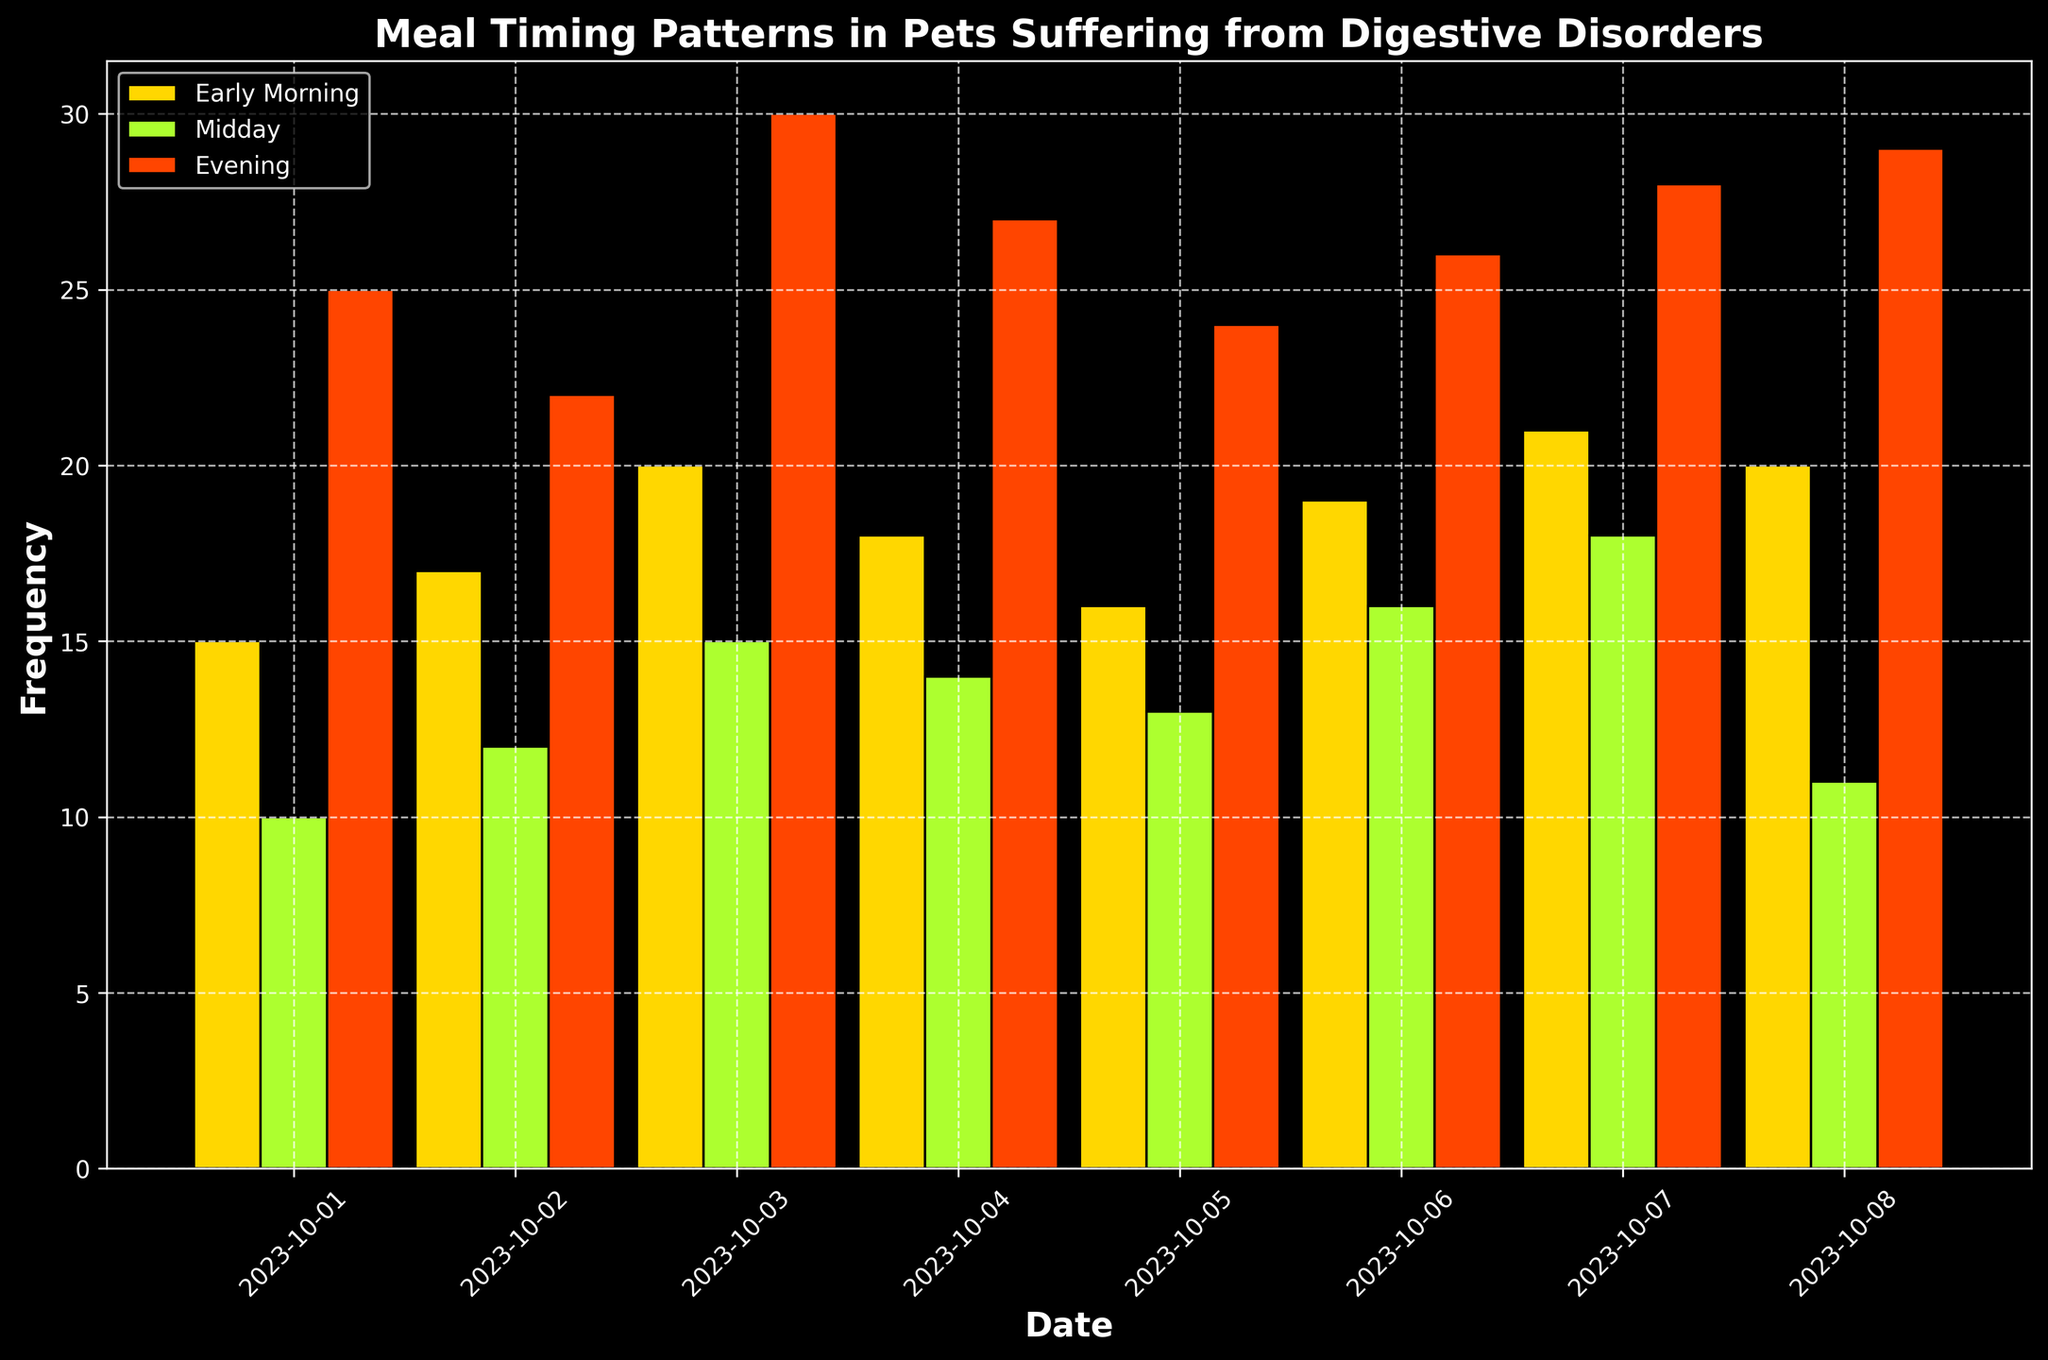1. Which meal timing category has the highest frequency on 2023-10-03? On 2023-10-03, the bar for the evening meal category is the tallest, representing the highest frequency among the meal timing categories
Answer: Evening 2. Compare the frequency of midday meals on 2023-10-02 and 2023-10-04. Which day has a higher frequency, and by how much? On 2023-10-02, the height of the midday bar is 12, and for 2023-10-04, it is 14. The difference is 14 - 12 = 2
Answer: 2023-10-04, by 2 3. What is the total frequency of evening meals from 2023-10-01 to 2023-10-08? Sum the frequencies of evening meals for each day: 25 + 22 + 30 + 27 + 24 + 26 + 28 + 29 = 211
Answer: 211 4. Which day shows the highest total frequency of meals across all categories? Calculate the total frequency for each day and compare:
2023-10-01: 15 + 10 + 25 = 50
2023-10-02: 17 + 12 + 22 = 51
2023-10-03: 20 + 15 + 30 = 65
2023-10-04: 18 + 14 + 27 = 59
2023-10-05: 16 + 13 + 24 = 53
2023-10-06: 19 + 16 + 26 = 61
2023-10-07: 21 + 18 + 28 = 67
2023-10-08: 20 + 11 + 29 = 60
The highest total frequency is on 2023-10-07 with 67
Answer: 2023-10-07 5. What is the average frequency of early morning meals across the given dates? Add the frequencies of early morning meals across all dates and divide by the number of dates: (15 + 17 + 20 + 18 + 16 + 19 + 21 + 20) / 8 = 146 / 8 = 18.25
Answer: 18.25 7. How does the frequency of midday meals on 2023-10-06 compare to the frequency of early morning meals on the same date? On 2023-10-06, the frequency of midday meals is 16, and the frequency of early morning meals is 19. Thus, the frequency of early morning meals is greater than that of midday meals by 3
Answer: Early morning meals are greater by 3 8. What is the visual pattern of frequency distribution for evening meals over the dates? The frequencies of evening meals over the dates show an increasing trend with minor fluctuations, reaching the highest value on 2023-10-03, decreasing slightly, and then increasing again. The visual pattern is a general upward trend
Answer: General upward trend 9. Do early morning meals have a uniform distribution across the dates, and if not, what pattern do they show? The frequencies vary slightly across the dates, with a general increase toward the later dates. They don't have a uniform distribution and show some fluctuations but tend to increase overall
Answer: Fluctuating but generally increasing 10. What is the combined frequency of midday meals on the last two dates? Sum the frequencies of midday meals on 2023-10-07 and 2023-10-08: 18 + 11 = 29
Answer: 29 